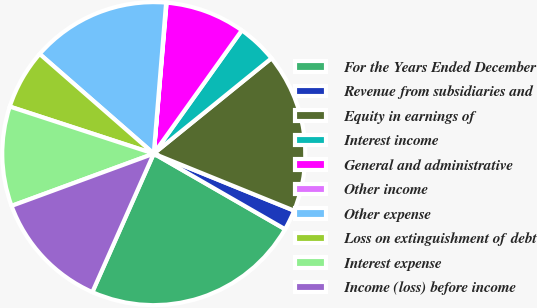Convert chart. <chart><loc_0><loc_0><loc_500><loc_500><pie_chart><fcel>For the Years Ended December<fcel>Revenue from subsidiaries and<fcel>Equity in earnings of<fcel>Interest income<fcel>General and administrative<fcel>Other income<fcel>Other expense<fcel>Loss on extinguishment of debt<fcel>Interest expense<fcel>Income (loss) before income<nl><fcel>23.33%<fcel>2.17%<fcel>16.98%<fcel>4.29%<fcel>8.52%<fcel>0.05%<fcel>14.87%<fcel>6.4%<fcel>10.63%<fcel>12.75%<nl></chart> 